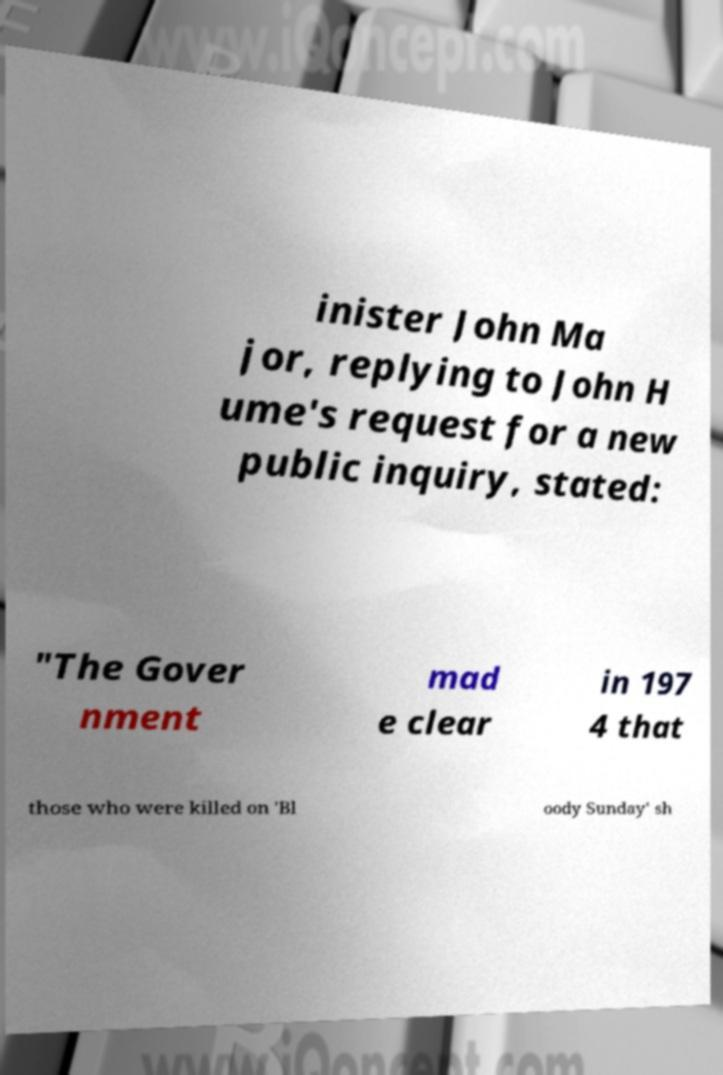Please identify and transcribe the text found in this image. inister John Ma jor, replying to John H ume's request for a new public inquiry, stated: "The Gover nment mad e clear in 197 4 that those who were killed on 'Bl oody Sunday' sh 